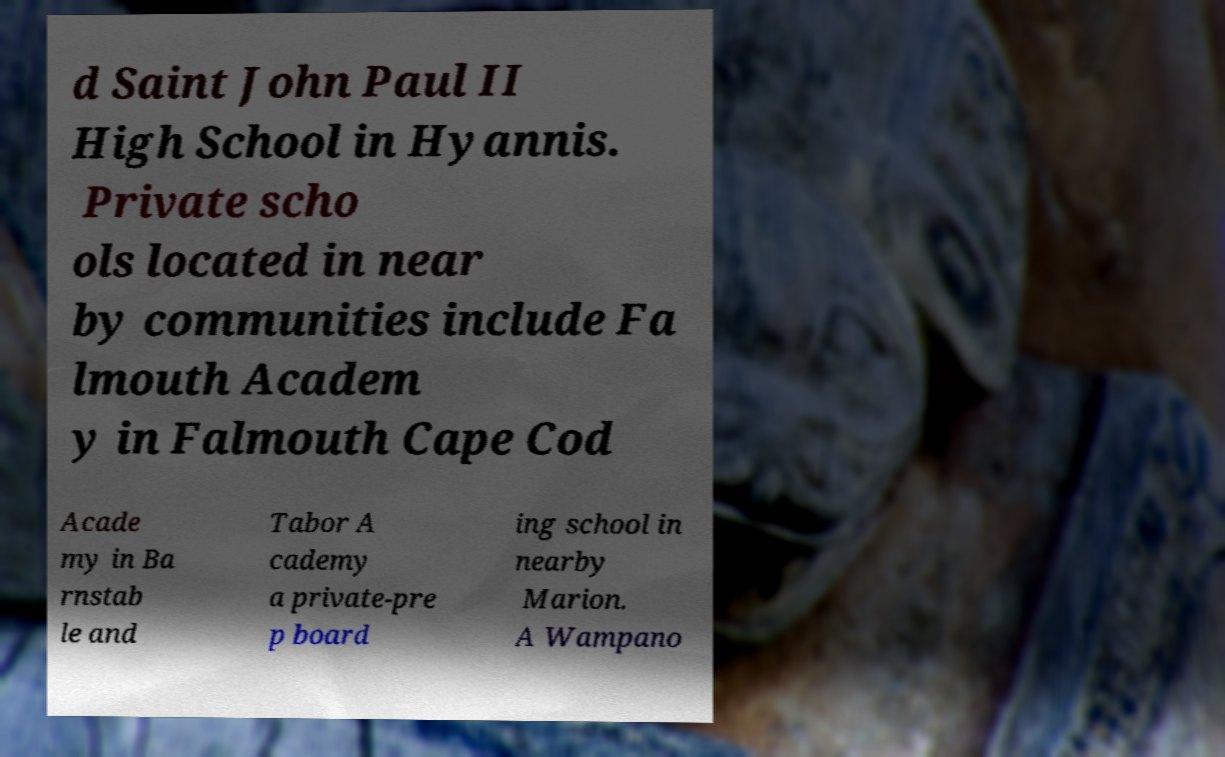Can you read and provide the text displayed in the image?This photo seems to have some interesting text. Can you extract and type it out for me? d Saint John Paul II High School in Hyannis. Private scho ols located in near by communities include Fa lmouth Academ y in Falmouth Cape Cod Acade my in Ba rnstab le and Tabor A cademy a private-pre p board ing school in nearby Marion. A Wampano 